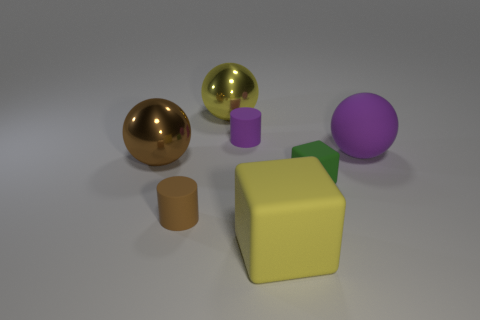Add 3 small purple cubes. How many objects exist? 10 Subtract all spheres. How many objects are left? 4 Subtract all big brown shiny spheres. Subtract all tiny purple matte things. How many objects are left? 5 Add 7 small green matte cubes. How many small green matte cubes are left? 8 Add 3 yellow shiny spheres. How many yellow shiny spheres exist? 4 Subtract 1 yellow cubes. How many objects are left? 6 